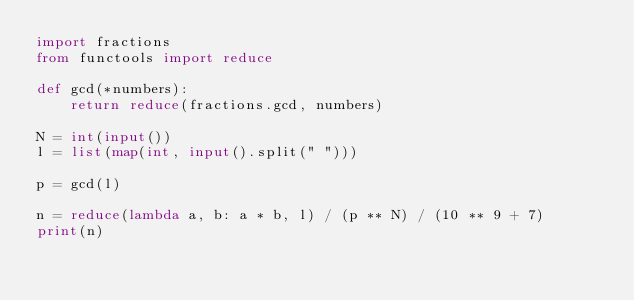Convert code to text. <code><loc_0><loc_0><loc_500><loc_500><_Python_>import fractions
from functools import reduce
 
def gcd(*numbers):
    return reduce(fractions.gcd, numbers)
 
N = int(input())
l = list(map(int, input().split(" ")))
 
p = gcd(l)
 
n = reduce(lambda a, b: a * b, l) / (p ** N) / (10 ** 9 + 7)
print(n)</code> 